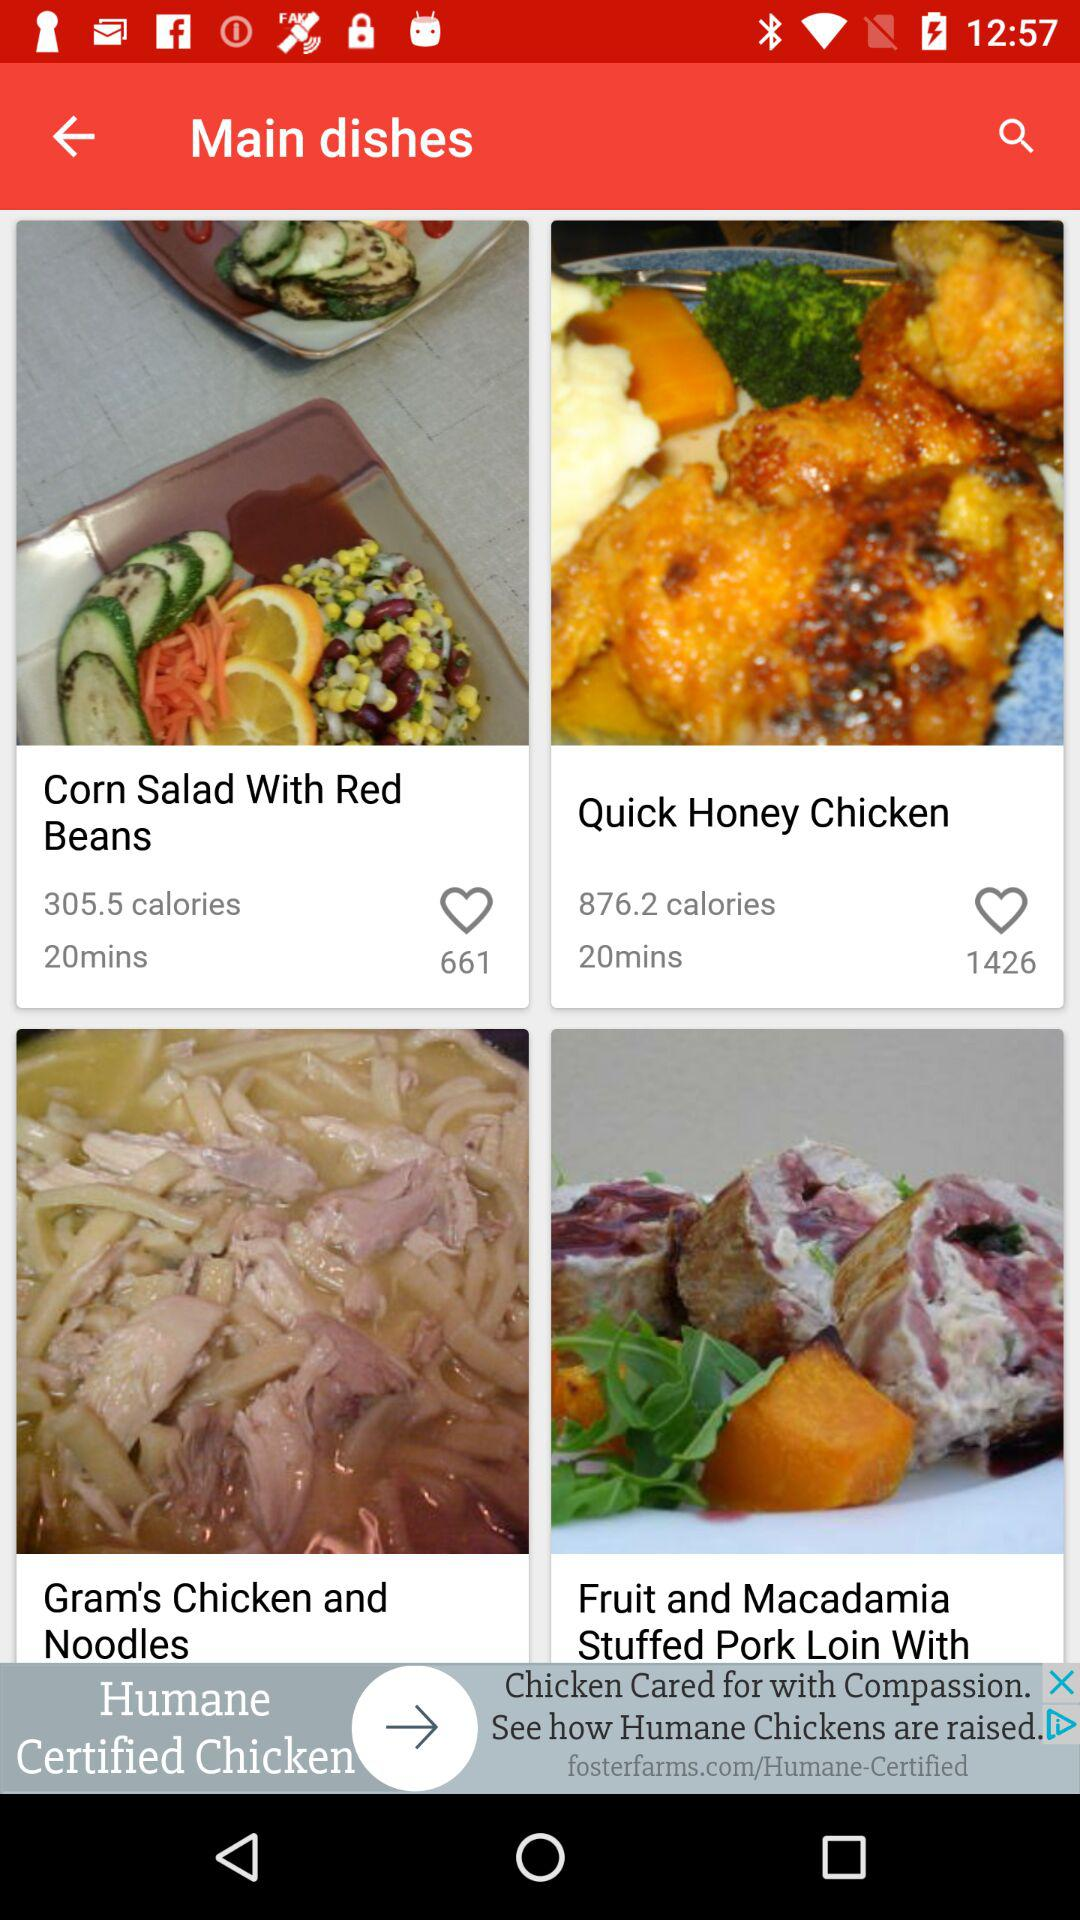How many calories are there in "Quick Honey Chicken"? There are 876.2 calories in "Quick Honey Chicken". 